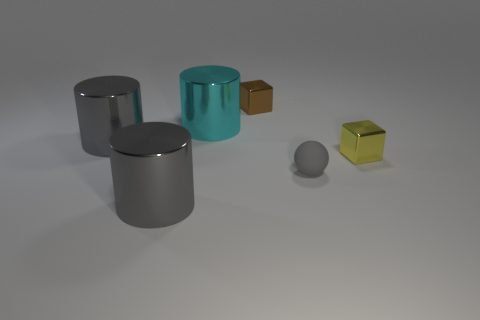Can you describe the lighting and reflections seen on the objects? Certainly! The objects exhibit soft shadows suggesting diffused lighting, likely from an overhead source. Each object displays distinct reflections and highlights that match its material properties: the gray objects show muted reflections indicative of a metallic surface, the teal cylinder has a glossy finish with sharper reflections, and the tiny cube displays the matte texture with minimal reflections. 